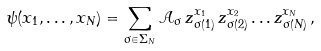<formula> <loc_0><loc_0><loc_500><loc_500>\psi ( x _ { 1 } , \dots , x _ { N } ) = \sum _ { \sigma \in \Sigma _ { N } } { \mathcal { A } } _ { \sigma } \, z _ { \sigma ( 1 ) } ^ { x _ { 1 } } \, z _ { \sigma ( 2 ) } ^ { x _ { 2 } } \dots z _ { \sigma ( N ) } ^ { x _ { N } } \, ,</formula> 